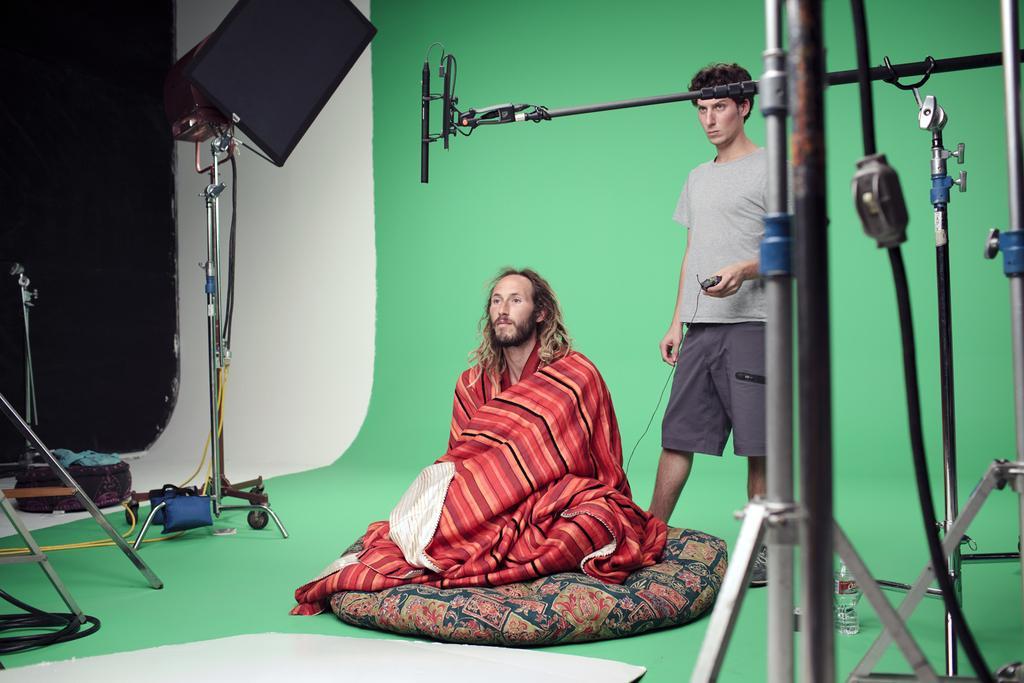Describe this image in one or two sentences. In this picture we can see a man sitting on the couch and covering with colorful cloth. Behind there is a boy wearing grey t-shirt is standing and looking to the camera. In the front we can see some camera, stands and microphone. Behind there is a green color paper in the background. 